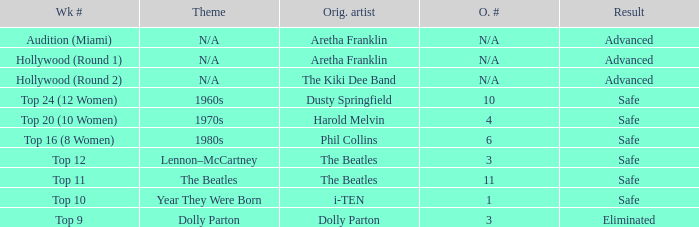What is the week number that has Dolly Parton as the theme? Top 9. 